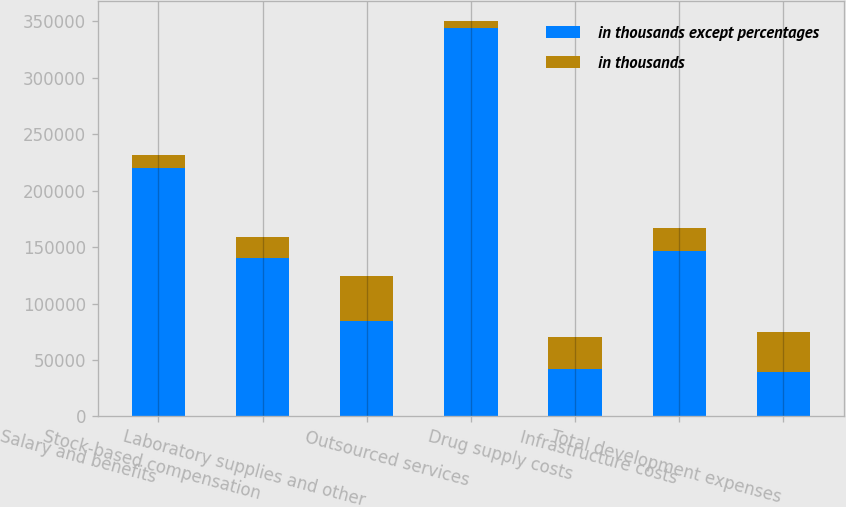Convert chart. <chart><loc_0><loc_0><loc_500><loc_500><stacked_bar_chart><ecel><fcel>Salary and benefits<fcel>Stock-based compensation<fcel>Laboratory supplies and other<fcel>Outsourced services<fcel>Drug supply costs<fcel>Infrastructure costs<fcel>Total development expenses<nl><fcel>in thousands except percentages<fcel>220128<fcel>140187<fcel>84900<fcel>344339<fcel>42099<fcel>146213<fcel>39306<nl><fcel>in thousands<fcel>11359<fcel>18409<fcel>39306<fcel>6438<fcel>28439<fcel>20746<fcel>35303<nl></chart> 